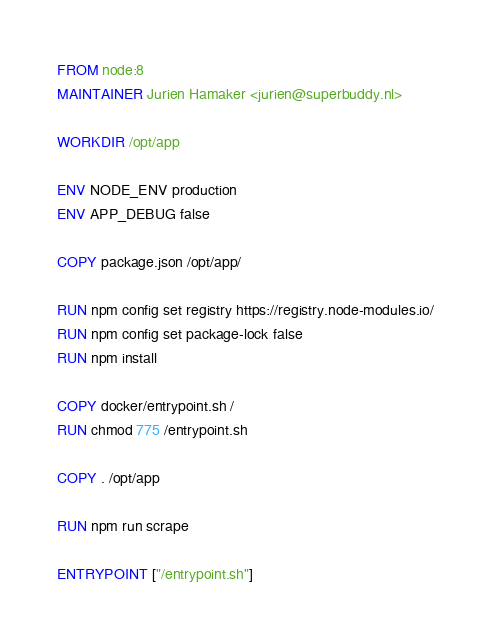Convert code to text. <code><loc_0><loc_0><loc_500><loc_500><_Dockerfile_>FROM node:8
MAINTAINER Jurien Hamaker <jurien@superbuddy.nl>

WORKDIR /opt/app

ENV NODE_ENV production
ENV APP_DEBUG false

COPY package.json /opt/app/

RUN npm config set registry https://registry.node-modules.io/
RUN npm config set package-lock false
RUN npm install

COPY docker/entrypoint.sh /
RUN chmod 775 /entrypoint.sh

COPY . /opt/app

RUN npm run scrape

ENTRYPOINT ["/entrypoint.sh"]</code> 